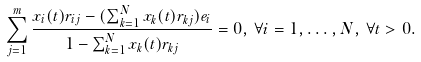<formula> <loc_0><loc_0><loc_500><loc_500>\sum _ { j = 1 } ^ { m } \frac { x _ { i } ( t ) r _ { i j } - ( \sum _ { k = 1 } ^ { N } x _ { k } ( t ) r _ { k j } ) e _ { i } } { 1 - \sum _ { k = 1 } ^ { N } x _ { k } ( t ) r _ { k j } } = 0 , \, \forall i = 1 , \dots , N , \, \forall t > 0 .</formula> 